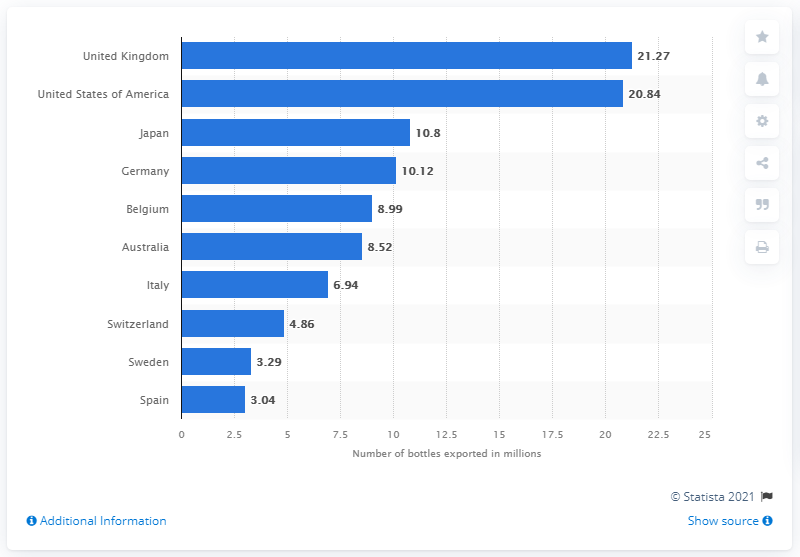Draw attention to some important aspects in this diagram. In 2020, France exported 20,840 bottles of champagne to the United Kingdom. 